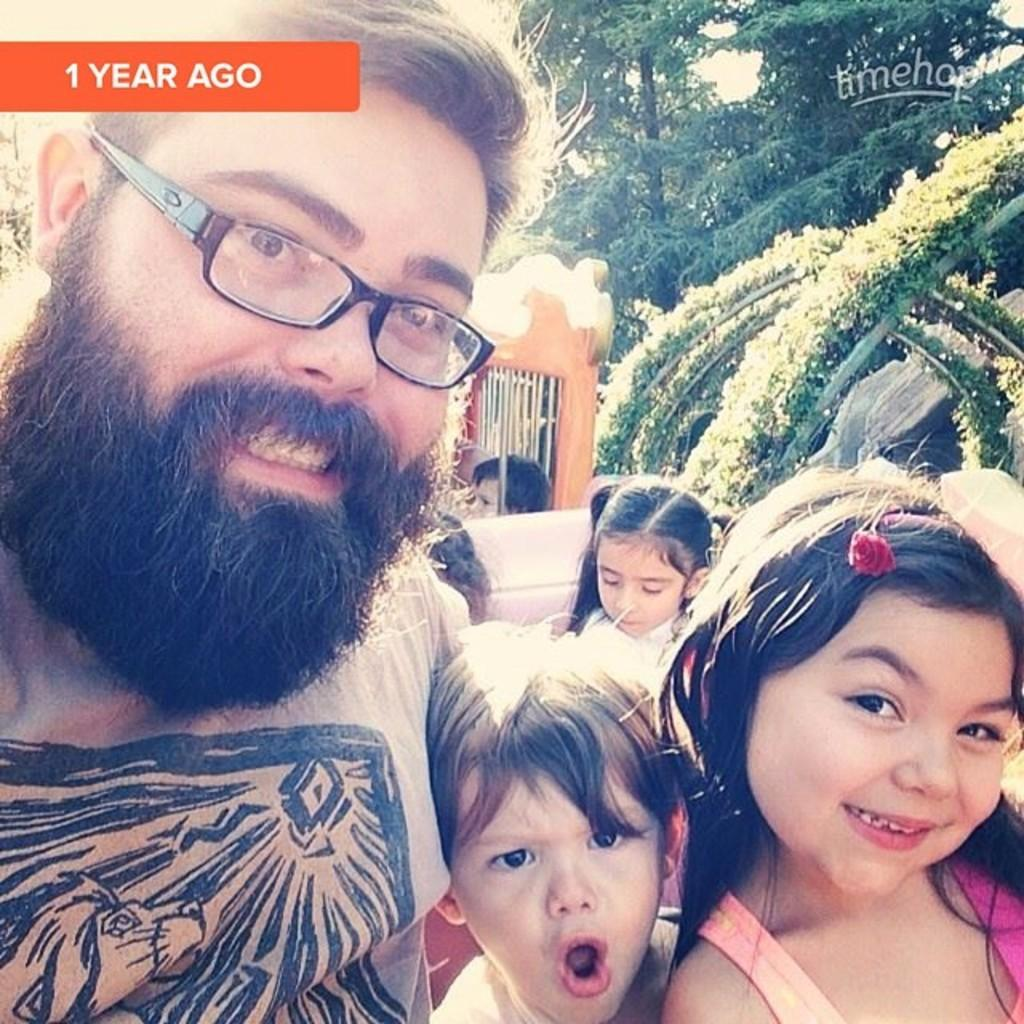Who is present in the image? There is a man and many children in the image. What can be observed about the man's appearance? The man is wearing spectacles. What are the people in the image wearing? The people in the image are wearing clothes. Can you describe any additional features in the image? There is a watermark, trees, a fence, and the sky is visible in the image. What type of fish can be seen swimming in the watermark in the image? There is no fish or water in the image, and therefore no such activity can be observed. How does the steam affect the visibility of the people in the image? There is no steam present in the image, so it does not affect the visibility of the people. 